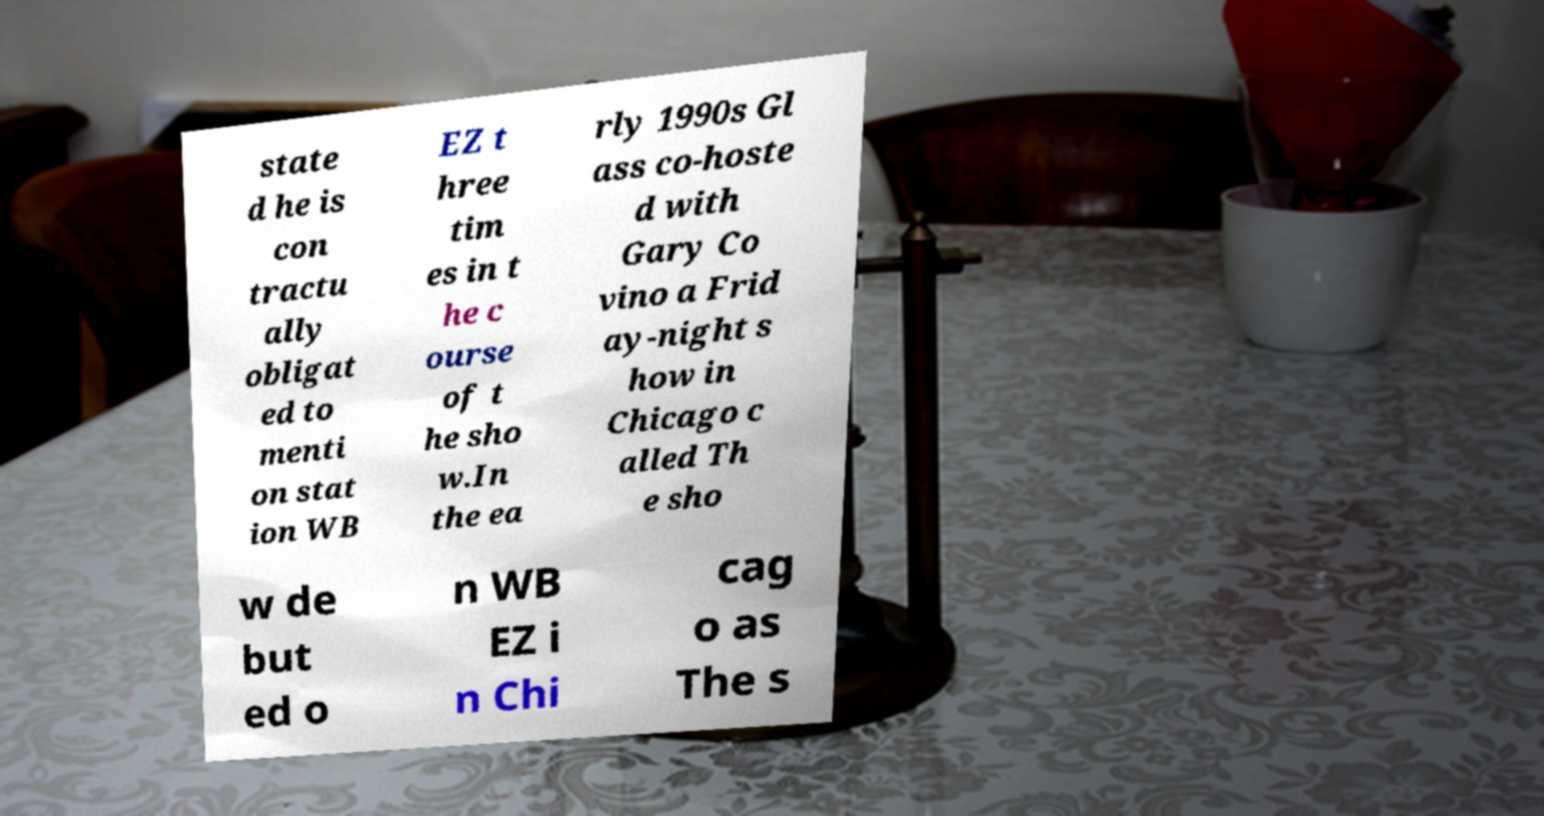I need the written content from this picture converted into text. Can you do that? state d he is con tractu ally obligat ed to menti on stat ion WB EZ t hree tim es in t he c ourse of t he sho w.In the ea rly 1990s Gl ass co-hoste d with Gary Co vino a Frid ay-night s how in Chicago c alled Th e sho w de but ed o n WB EZ i n Chi cag o as The s 